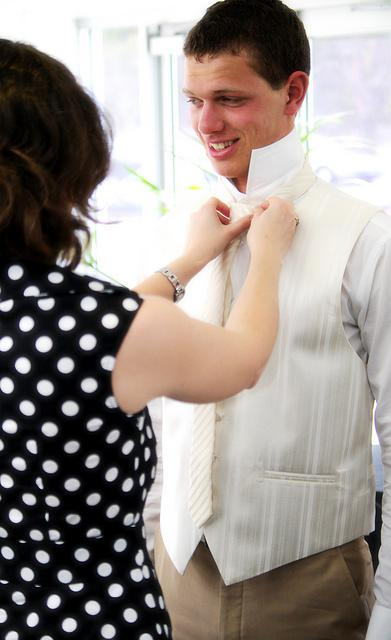What is the woman helping to do? tie tie 